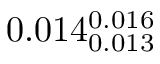<formula> <loc_0><loc_0><loc_500><loc_500>0 . 0 1 4 _ { 0 . 0 1 3 } ^ { 0 . 0 1 6 }</formula> 